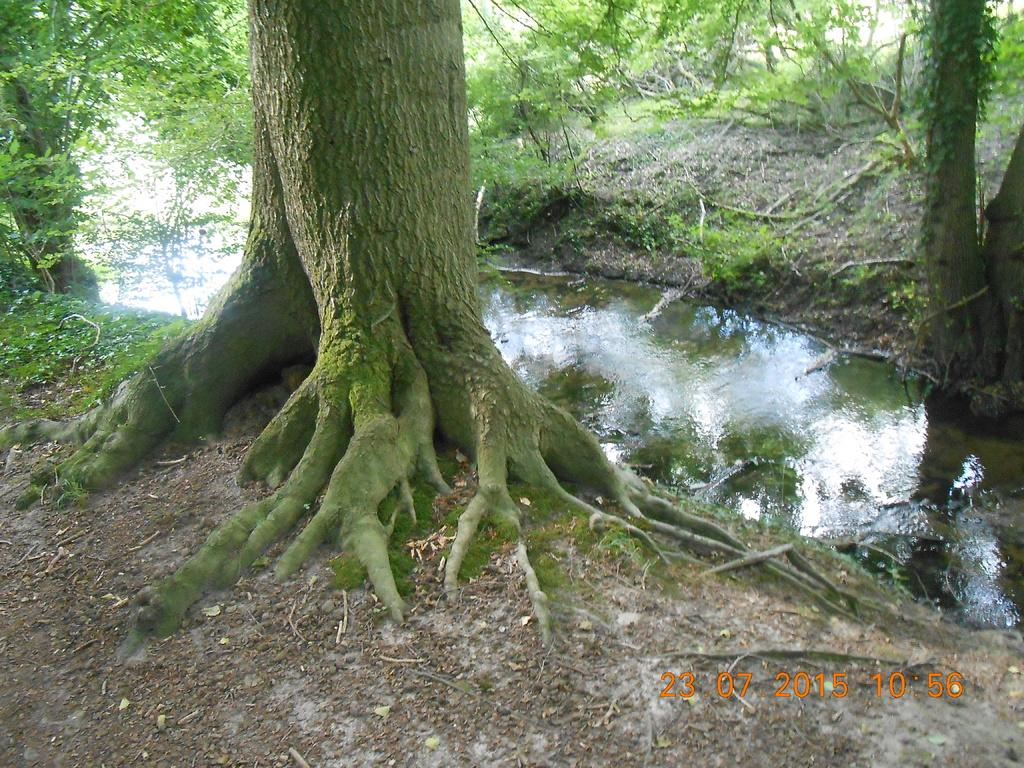What is located at the edges of the river in the foreground of the image? There is a trunk at the edges of the river in the foreground of the image. What can be seen on the right side of the image? There is a tree on the right side of the image. What is visible in the background of the image? There are trees visible in the background of the image. Can you describe the haircut of the snake in the image? There is no snake present in the image, and therefore no haircut can be described. What type of rat can be seen interacting with the trees in the image? There is no rat present in the image; only the trunk, trees, and river are visible. 